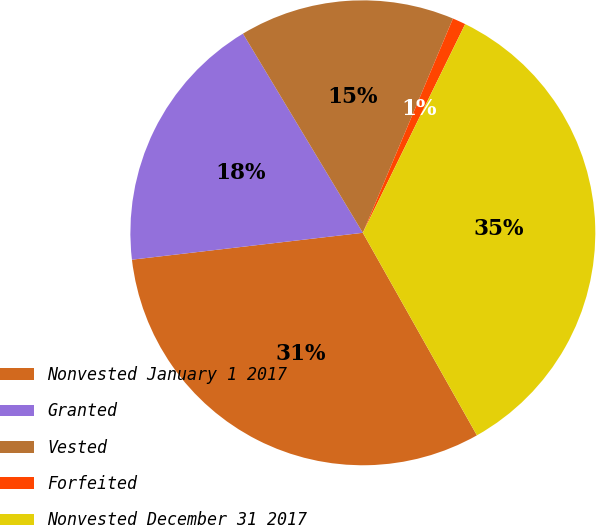Convert chart to OTSL. <chart><loc_0><loc_0><loc_500><loc_500><pie_chart><fcel>Nonvested January 1 2017<fcel>Granted<fcel>Vested<fcel>Forfeited<fcel>Nonvested December 31 2017<nl><fcel>31.32%<fcel>18.22%<fcel>14.96%<fcel>0.92%<fcel>34.58%<nl></chart> 